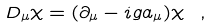<formula> <loc_0><loc_0><loc_500><loc_500>D _ { \mu } \chi = ( \partial _ { \mu } - i g a _ { \mu } ) \chi \ ,</formula> 